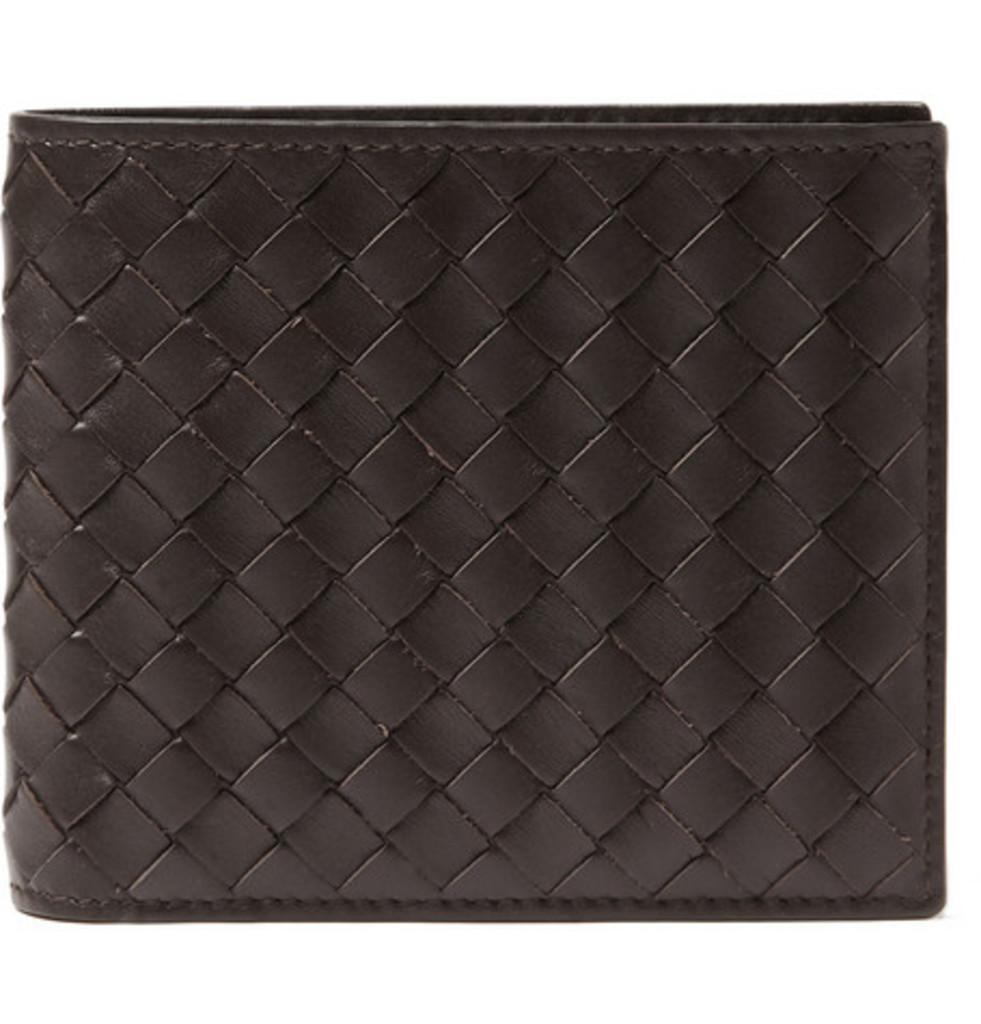What object can be seen in the image? There is a wallet in the image. What is the color of the wallet? The wallet is black in color. What type of brush is used to make the decision on the table in the image? There is no table or brush present in the image; it only features a black wallet. 